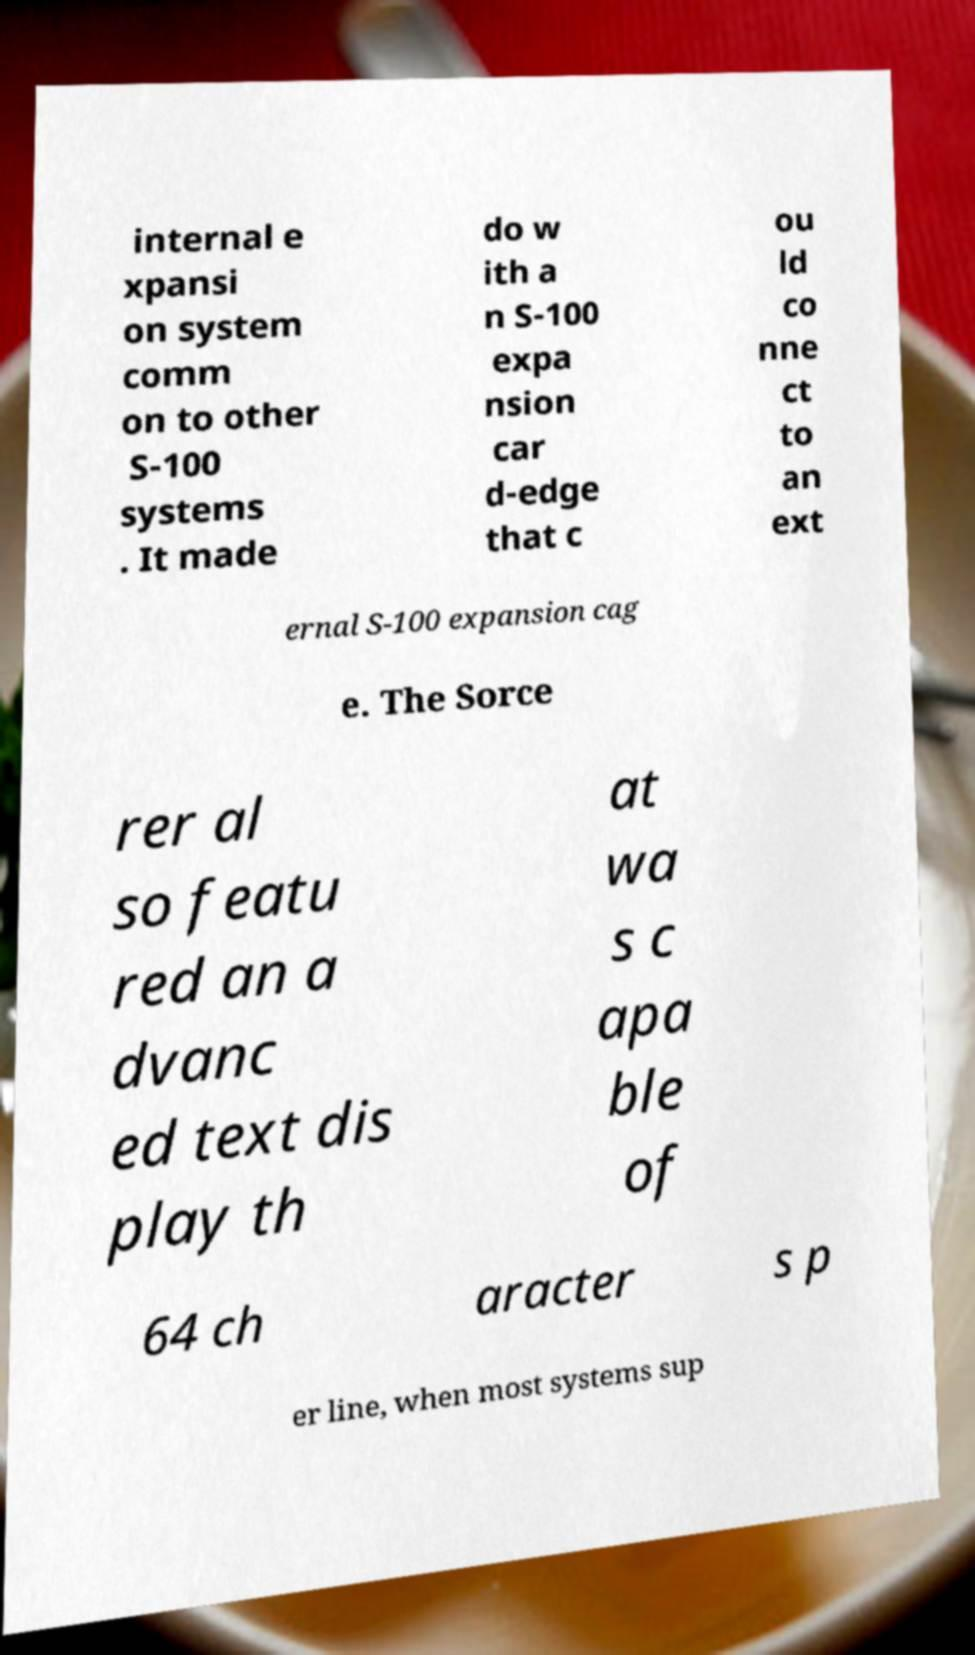Can you accurately transcribe the text from the provided image for me? internal e xpansi on system comm on to other S-100 systems . It made do w ith a n S-100 expa nsion car d-edge that c ou ld co nne ct to an ext ernal S-100 expansion cag e. The Sorce rer al so featu red an a dvanc ed text dis play th at wa s c apa ble of 64 ch aracter s p er line, when most systems sup 